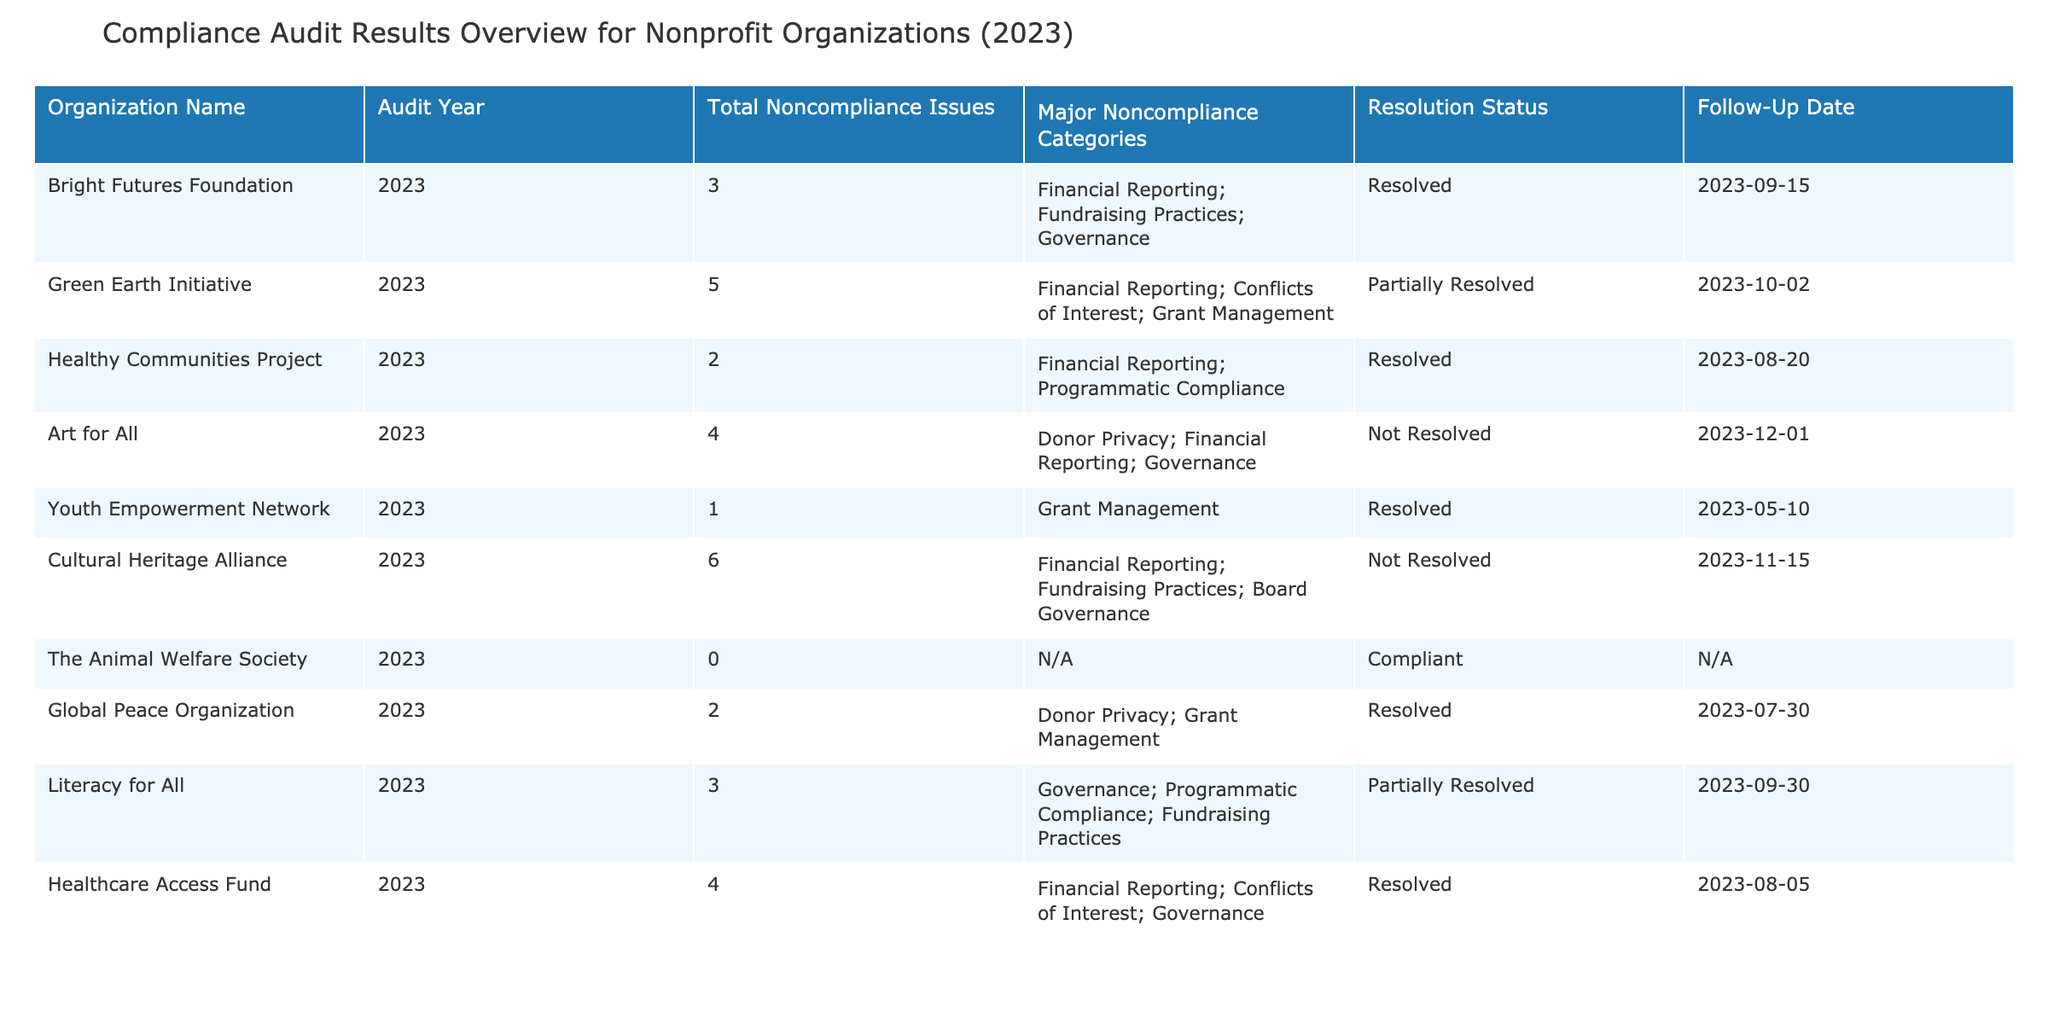What is the total number of noncompliance issues for the Green Earth Initiative? The table shows that the Green Earth Initiative has a total of 5 noncompliance issues listed in the column for Total Noncompliance Issues.
Answer: 5 Which organization has the highest number of total noncompliance issues? The Cultural Heritage Alliance has 6 total noncompliance issues, which is the highest among all organizations listed in the table.
Answer: Cultural Heritage Alliance How many organizations are fully compliant? The table lists one organization, The Animal Welfare Society, as having zero noncompliance issues which indicates full compliance.
Answer: 1 What is the average number of total noncompliance issues among all organizations? First, we add up the total noncompliance issues: 3 + 5 + 2 + 4 + 1 + 6 + 0 + 2 + 3 + 4 = 30. There are 10 organizations total, so the average is 30 divided by 10, which equals 3.
Answer: 3 Is there any organization with unresolved issues that also has a resolution status of partially resolved? Yes, Green Earth Initiative and Literacy for All are both listed as having unresolved issues and a resolution status of partially resolved as indicated in their respective rows in the table.
Answer: Yes What are the major noncompliance categories for the organization that has the least number of noncompliance issues? The Youth Empowerment Network has the least number of noncompliance issues (1). The major noncompliance category for this organization is Grant Management, as listed in the table.
Answer: Grant Management How many organizations have noncompliance issues related to Financial Reporting? The organizations that have issues related to Financial Reporting are Bright Futures Foundation, Green Earth Initiative, Art for All, Healthcare Access Fund, and Cultural Heritage Alliance. This totals to 5 organizations.
Answer: 5 Which organization has the next follow-up date after Art for All? Art for All has a follow-up date of 2023-12-01. The next follow-up date is for Cultural Heritage Alliance on 2023-11-15. This follows Art for All's date in the chronological order of the follow-up dates listed in the table.
Answer: Cultural Heritage Alliance 